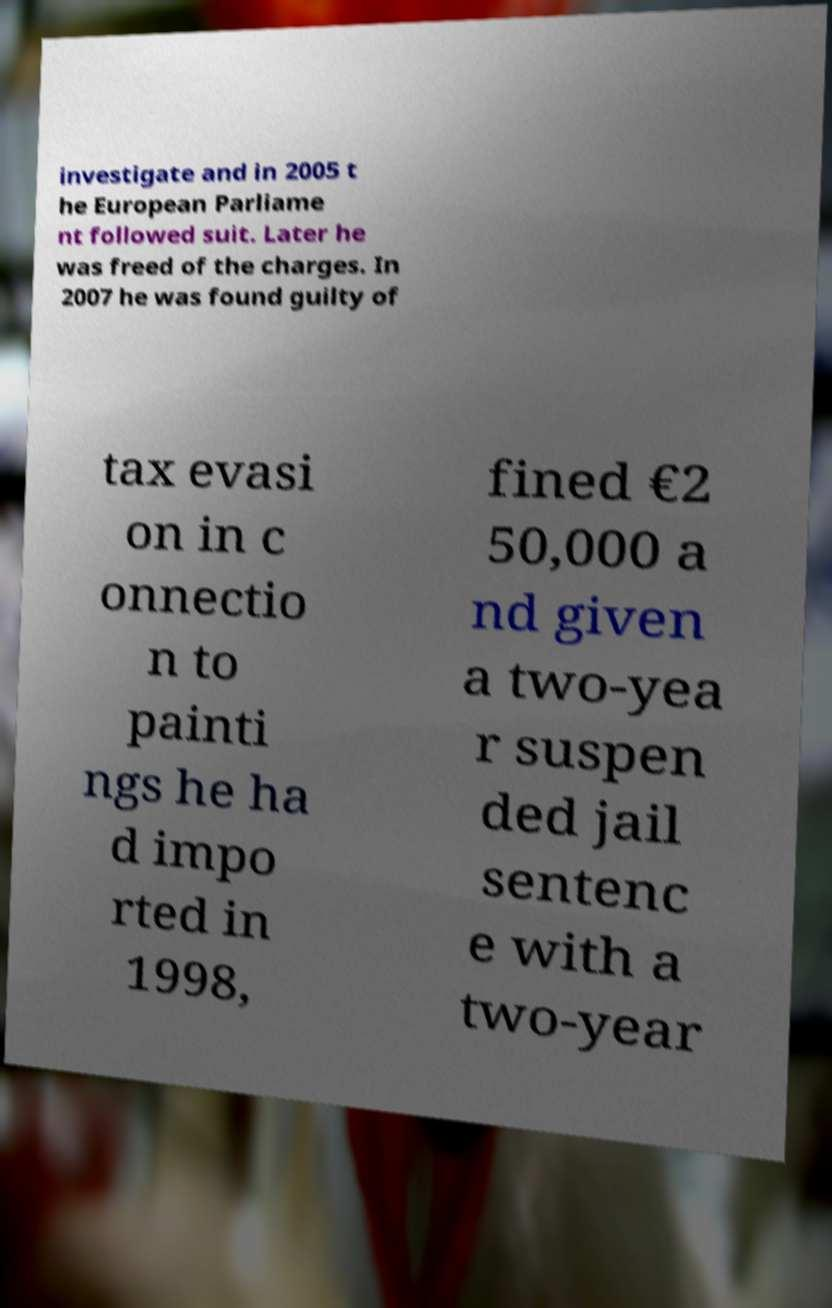Please identify and transcribe the text found in this image. investigate and in 2005 t he European Parliame nt followed suit. Later he was freed of the charges. In 2007 he was found guilty of tax evasi on in c onnectio n to painti ngs he ha d impo rted in 1998, fined €2 50,000 a nd given a two-yea r suspen ded jail sentenc e with a two-year 